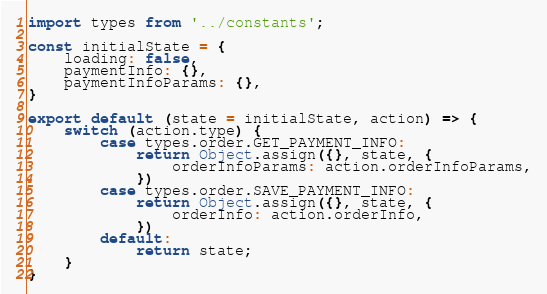<code> <loc_0><loc_0><loc_500><loc_500><_JavaScript_>import types from '../constants';

const initialState = {
    loading: false,
    paymentInfo: {},
    paymentInfoParams: {},
}

export default (state = initialState, action) => {
    switch (action.type) {
        case types.order.GET_PAYMENT_INFO:
            return Object.assign({}, state, {
                orderInfoParams: action.orderInfoParams,
            })
        case types.order.SAVE_PAYMENT_INFO:
            return Object.assign({}, state, {
                orderInfo: action.orderInfo,
            })
        default:
            return state;
    }
}
</code> 